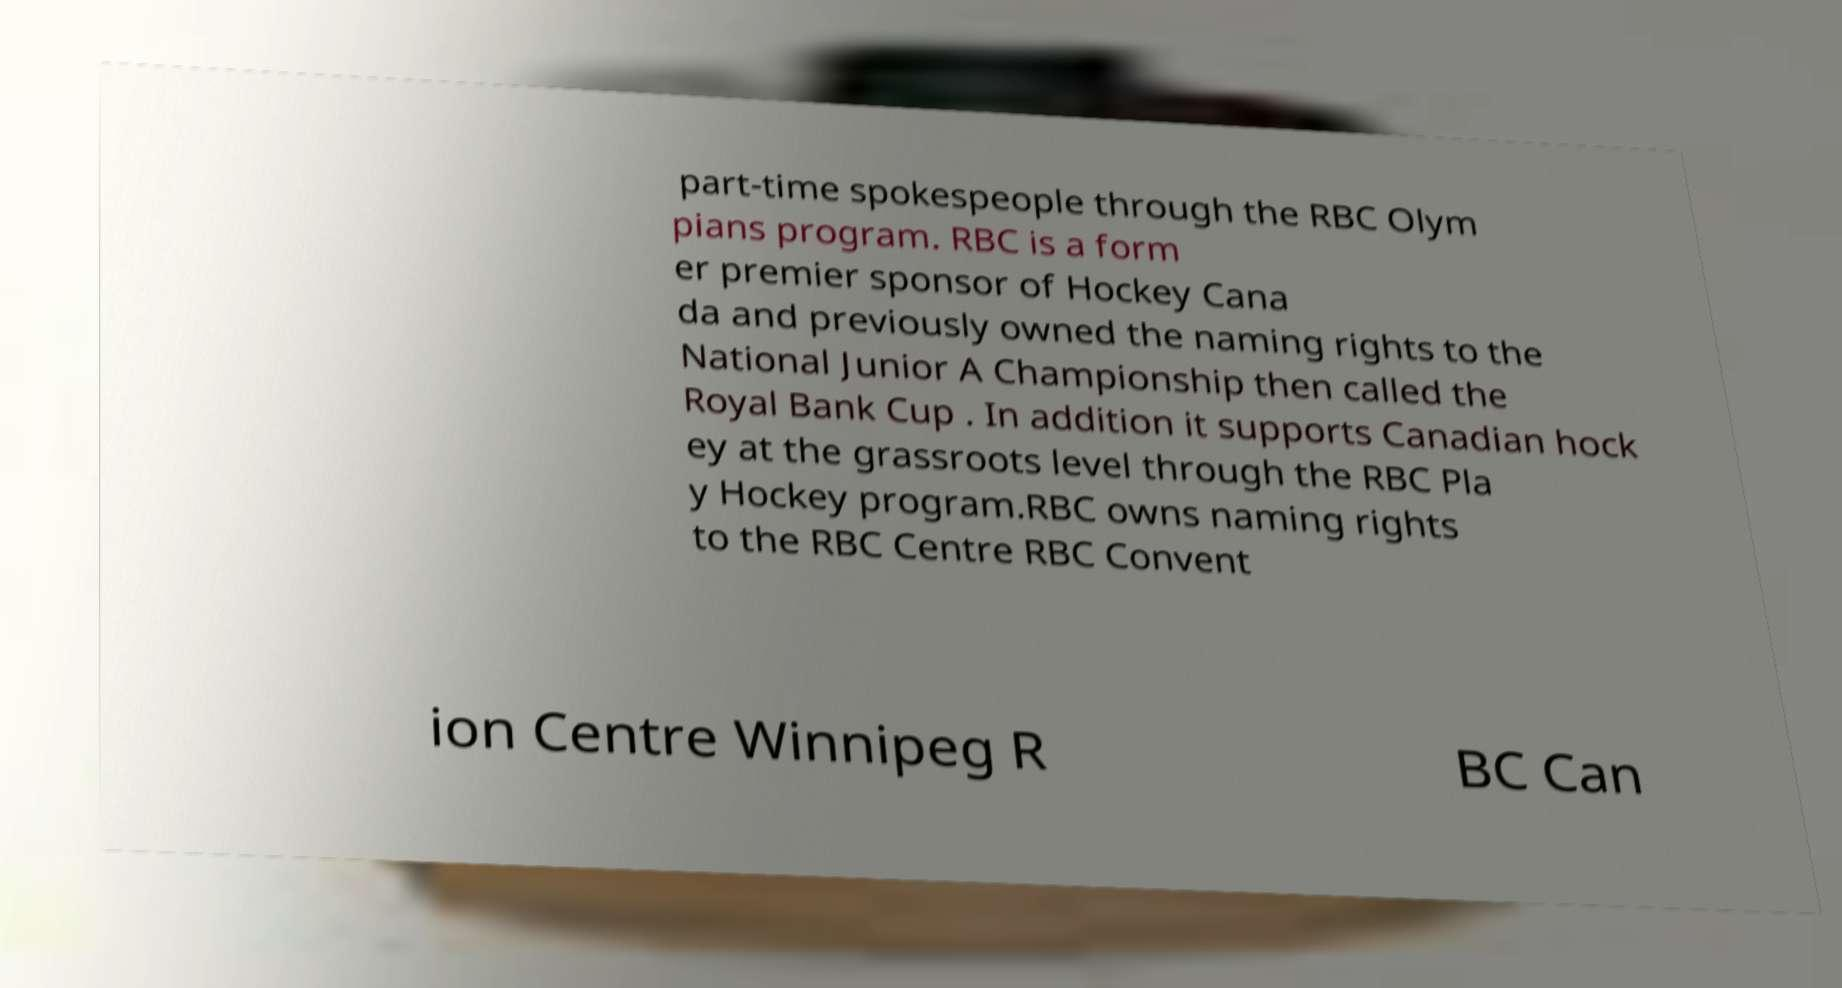For documentation purposes, I need the text within this image transcribed. Could you provide that? part-time spokespeople through the RBC Olym pians program. RBC is a form er premier sponsor of Hockey Cana da and previously owned the naming rights to the National Junior A Championship then called the Royal Bank Cup . In addition it supports Canadian hock ey at the grassroots level through the RBC Pla y Hockey program.RBC owns naming rights to the RBC Centre RBC Convent ion Centre Winnipeg R BC Can 